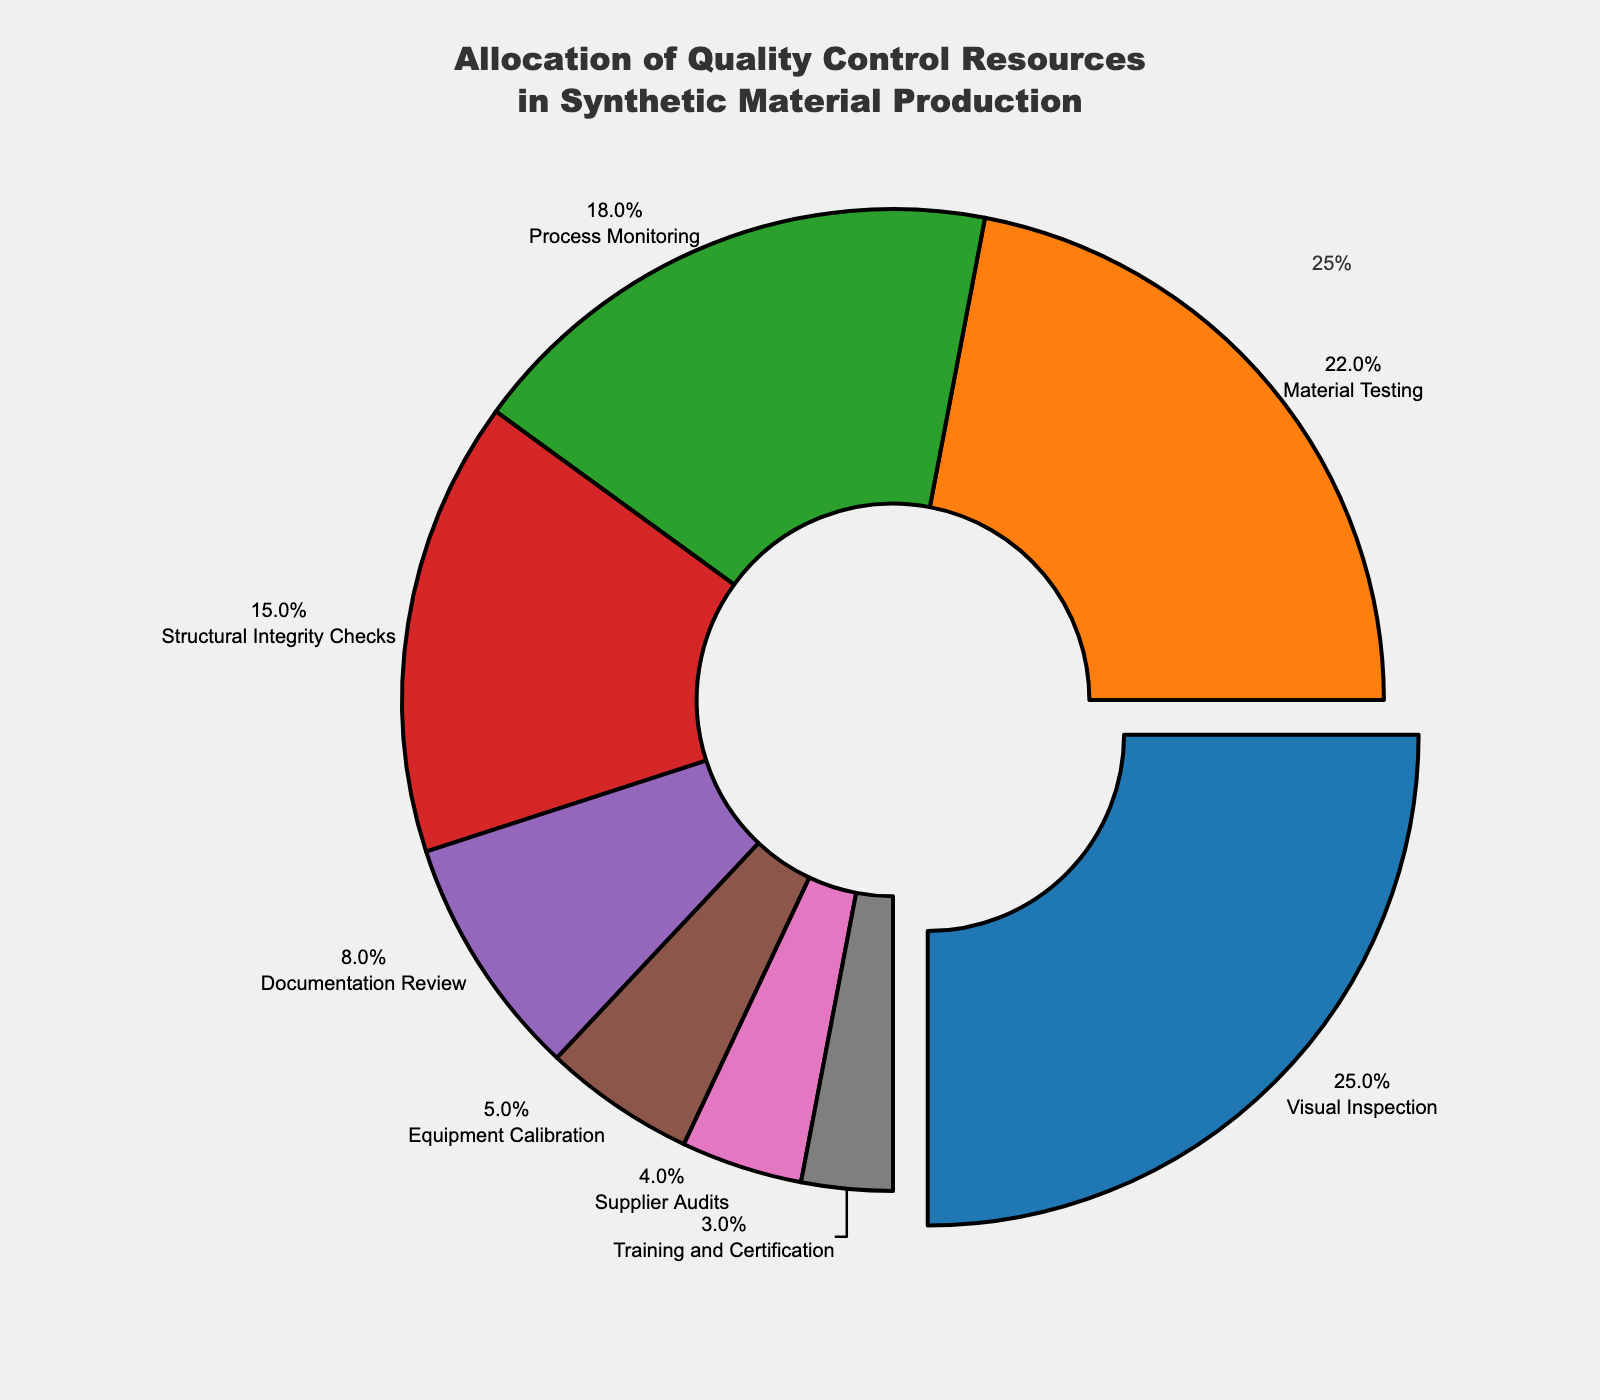What is the largest allocation of quality control resources? The figure depicts the allocation of quality control resources in synthetic material production. The segment labeled "Visual Inspection" occupies the largest portion of the pie chart.
Answer: Visual Inspection Which quality control category is allocated the least resources? By referring to the chart, the smallest slice corresponds to "Training and Certification," making it the least allocated category.
Answer: Training and Certification What is the combined percentage of resources allocated to Structural Integrity Checks and Documentation Review? Adding the percentages: Structural Integrity Checks (15%) and Documentation Review (8%) gives 15% + 8% = 23%.
Answer: 23% Compare the allocation resources between Material Testing and Equipment Calibration. Which one has more resources allocated? By analyzing the chart, Material Testing has a larger segment (22%) compared to Equipment Calibration (5%).
Answer: Material Testing Which categories contribute to more than 20% of the total resources combined? Visual Inspection (25%) and Material Testing (22%) each contribute more than 20%.
Answer: Visual Inspection, Material Testing What is the difference in resource allocation between Visual Inspection and Supplier Audits? Visual Inspection is allocated 25% and Supplier Audits 4%. The difference is 25% - 4% = 21%.
Answer: 21% What is the total percentage allocation for the categories with less than 10% each? Adding the percentages: Documentation Review (8%), Equipment Calibration (5%), Supplier Audits (4%), Training and Certification (3%) results in 8% + 5% + 4% + 3% = 20%.
Answer: 20% Which categories are visually represented with similar-sized slices in the pie chart? Process Monitoring (18%) and Structural Integrity Checks (15%) have similarly sized slices in the pie chart.
Answer: Process Monitoring, Structural Integrity Checks If 10% of the total resources need to be reallocated from Visual Inspection to Process Monitoring, what would be the new allocation percentages for these two categories? Visual Inspection originally has 25%, and Process Monitoring 18%. After reallocating 10%, Visual Inspection would be 25% - 10% = 15% and Process Monitoring would be 18% + 10% = 28%.
Answer: Visual Inspection 15%, Process Monitoring 28% How do the combined resources allocated to Process Monitoring and Structural Integrity Checks compare to those allocated to Visual Inspection alone? Process Monitoring (18%) + Structural Integrity Checks (15%) = 33%. Visual Inspection alone is 25%. Hence, the combined resources for Process Monitoring and Structural Integrity Checks (33%) are greater than those for Visual Inspection (25%).
Answer: Greater 